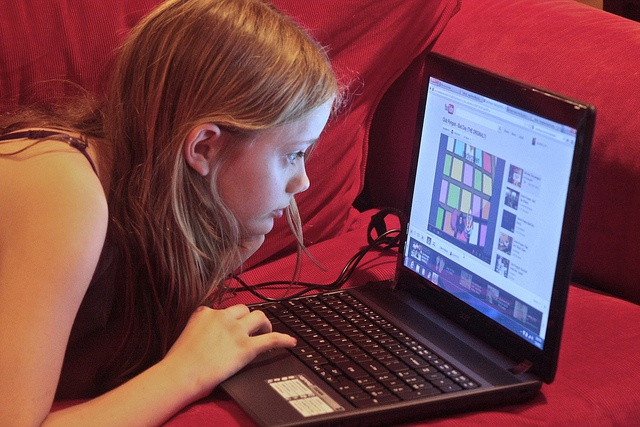Describe the objects in this image and their specific colors. I can see a couch in maroon, black, brown, tan, and lightblue tones in this image. 